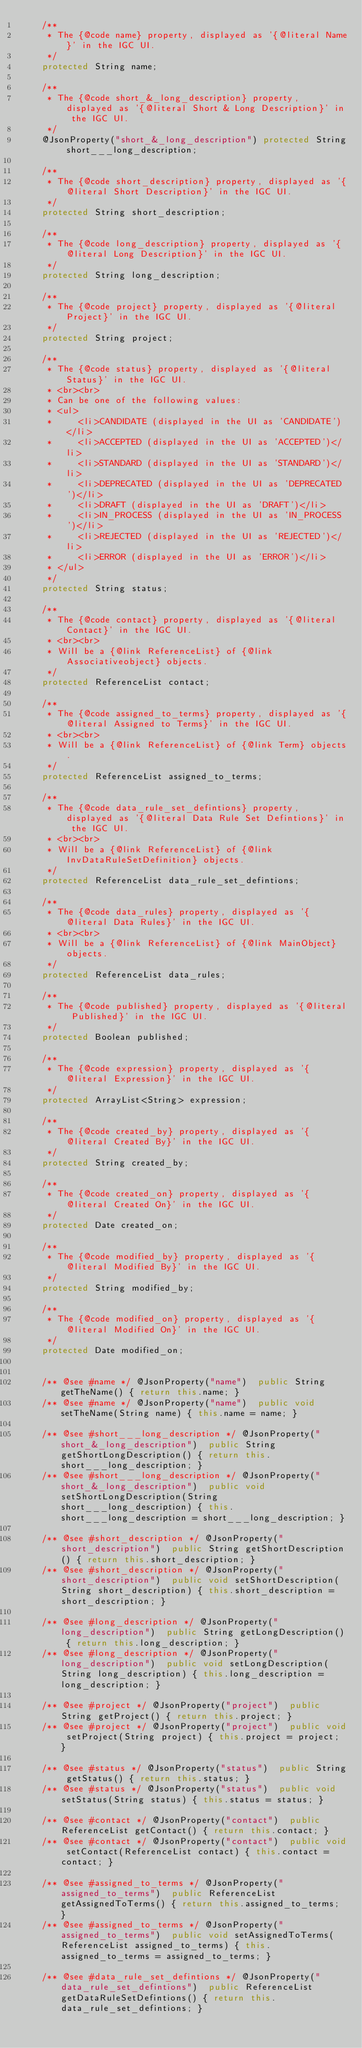<code> <loc_0><loc_0><loc_500><loc_500><_Java_>    /**
     * The {@code name} property, displayed as '{@literal Name}' in the IGC UI.
     */
    protected String name;

    /**
     * The {@code short_&_long_description} property, displayed as '{@literal Short & Long Description}' in the IGC UI.
     */
    @JsonProperty("short_&_long_description") protected String short___long_description;

    /**
     * The {@code short_description} property, displayed as '{@literal Short Description}' in the IGC UI.
     */
    protected String short_description;

    /**
     * The {@code long_description} property, displayed as '{@literal Long Description}' in the IGC UI.
     */
    protected String long_description;

    /**
     * The {@code project} property, displayed as '{@literal Project}' in the IGC UI.
     */
    protected String project;

    /**
     * The {@code status} property, displayed as '{@literal Status}' in the IGC UI.
     * <br><br>
     * Can be one of the following values:
     * <ul>
     *     <li>CANDIDATE (displayed in the UI as 'CANDIDATE')</li>
     *     <li>ACCEPTED (displayed in the UI as 'ACCEPTED')</li>
     *     <li>STANDARD (displayed in the UI as 'STANDARD')</li>
     *     <li>DEPRECATED (displayed in the UI as 'DEPRECATED')</li>
     *     <li>DRAFT (displayed in the UI as 'DRAFT')</li>
     *     <li>IN_PROCESS (displayed in the UI as 'IN_PROCESS')</li>
     *     <li>REJECTED (displayed in the UI as 'REJECTED')</li>
     *     <li>ERROR (displayed in the UI as 'ERROR')</li>
     * </ul>
     */
    protected String status;

    /**
     * The {@code contact} property, displayed as '{@literal Contact}' in the IGC UI.
     * <br><br>
     * Will be a {@link ReferenceList} of {@link Associativeobject} objects.
     */
    protected ReferenceList contact;

    /**
     * The {@code assigned_to_terms} property, displayed as '{@literal Assigned to Terms}' in the IGC UI.
     * <br><br>
     * Will be a {@link ReferenceList} of {@link Term} objects.
     */
    protected ReferenceList assigned_to_terms;

    /**
     * The {@code data_rule_set_defintions} property, displayed as '{@literal Data Rule Set Defintions}' in the IGC UI.
     * <br><br>
     * Will be a {@link ReferenceList} of {@link InvDataRuleSetDefinition} objects.
     */
    protected ReferenceList data_rule_set_defintions;

    /**
     * The {@code data_rules} property, displayed as '{@literal Data Rules}' in the IGC UI.
     * <br><br>
     * Will be a {@link ReferenceList} of {@link MainObject} objects.
     */
    protected ReferenceList data_rules;

    /**
     * The {@code published} property, displayed as '{@literal Published}' in the IGC UI.
     */
    protected Boolean published;

    /**
     * The {@code expression} property, displayed as '{@literal Expression}' in the IGC UI.
     */
    protected ArrayList<String> expression;

    /**
     * The {@code created_by} property, displayed as '{@literal Created By}' in the IGC UI.
     */
    protected String created_by;

    /**
     * The {@code created_on} property, displayed as '{@literal Created On}' in the IGC UI.
     */
    protected Date created_on;

    /**
     * The {@code modified_by} property, displayed as '{@literal Modified By}' in the IGC UI.
     */
    protected String modified_by;

    /**
     * The {@code modified_on} property, displayed as '{@literal Modified On}' in the IGC UI.
     */
    protected Date modified_on;


    /** @see #name */ @JsonProperty("name")  public String getTheName() { return this.name; }
    /** @see #name */ @JsonProperty("name")  public void setTheName(String name) { this.name = name; }

    /** @see #short___long_description */ @JsonProperty("short_&_long_description")  public String getShortLongDescription() { return this.short___long_description; }
    /** @see #short___long_description */ @JsonProperty("short_&_long_description")  public void setShortLongDescription(String short___long_description) { this.short___long_description = short___long_description; }

    /** @see #short_description */ @JsonProperty("short_description")  public String getShortDescription() { return this.short_description; }
    /** @see #short_description */ @JsonProperty("short_description")  public void setShortDescription(String short_description) { this.short_description = short_description; }

    /** @see #long_description */ @JsonProperty("long_description")  public String getLongDescription() { return this.long_description; }
    /** @see #long_description */ @JsonProperty("long_description")  public void setLongDescription(String long_description) { this.long_description = long_description; }

    /** @see #project */ @JsonProperty("project")  public String getProject() { return this.project; }
    /** @see #project */ @JsonProperty("project")  public void setProject(String project) { this.project = project; }

    /** @see #status */ @JsonProperty("status")  public String getStatus() { return this.status; }
    /** @see #status */ @JsonProperty("status")  public void setStatus(String status) { this.status = status; }

    /** @see #contact */ @JsonProperty("contact")  public ReferenceList getContact() { return this.contact; }
    /** @see #contact */ @JsonProperty("contact")  public void setContact(ReferenceList contact) { this.contact = contact; }

    /** @see #assigned_to_terms */ @JsonProperty("assigned_to_terms")  public ReferenceList getAssignedToTerms() { return this.assigned_to_terms; }
    /** @see #assigned_to_terms */ @JsonProperty("assigned_to_terms")  public void setAssignedToTerms(ReferenceList assigned_to_terms) { this.assigned_to_terms = assigned_to_terms; }

    /** @see #data_rule_set_defintions */ @JsonProperty("data_rule_set_defintions")  public ReferenceList getDataRuleSetDefintions() { return this.data_rule_set_defintions; }</code> 